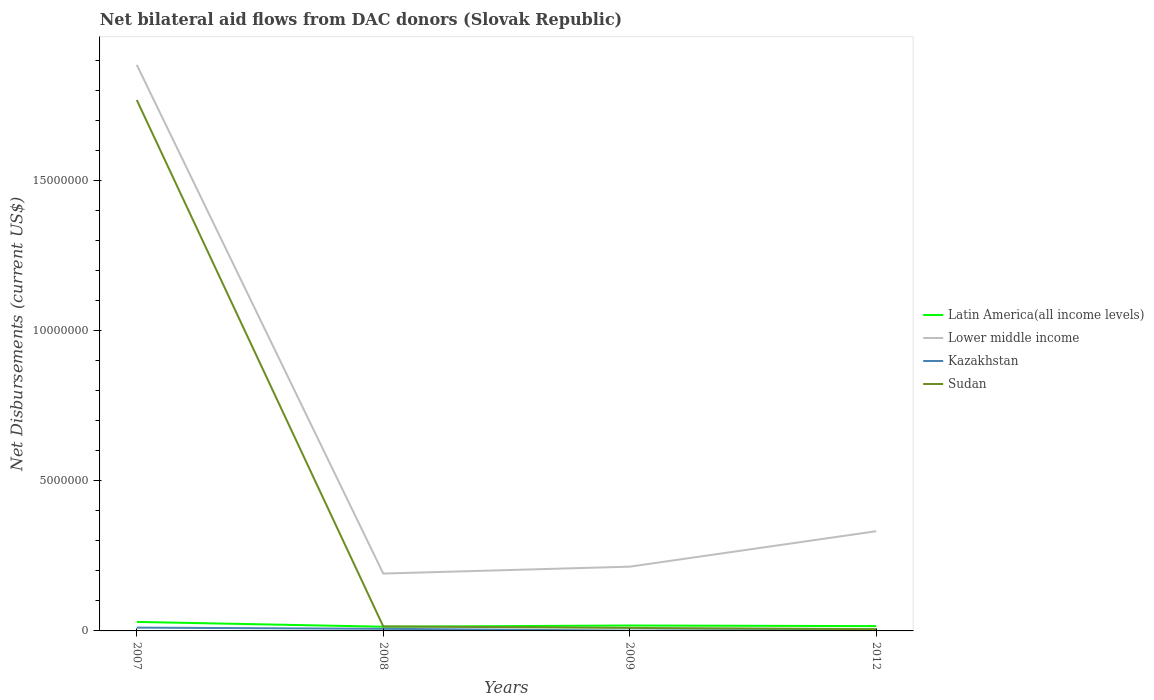Does the line corresponding to Lower middle income intersect with the line corresponding to Latin America(all income levels)?
Offer a very short reply. No. Is the number of lines equal to the number of legend labels?
Ensure brevity in your answer.  Yes. Across all years, what is the maximum net bilateral aid flows in Lower middle income?
Your answer should be compact. 1.91e+06. What is the difference between the highest and the second highest net bilateral aid flows in Latin America(all income levels)?
Your answer should be very brief. 1.60e+05. What is the difference between the highest and the lowest net bilateral aid flows in Sudan?
Provide a succinct answer. 1. Is the net bilateral aid flows in Lower middle income strictly greater than the net bilateral aid flows in Sudan over the years?
Your answer should be compact. No. How many lines are there?
Your response must be concise. 4. Does the graph contain any zero values?
Your response must be concise. No. Does the graph contain grids?
Your response must be concise. No. Where does the legend appear in the graph?
Provide a short and direct response. Center right. How are the legend labels stacked?
Keep it short and to the point. Vertical. What is the title of the graph?
Make the answer very short. Net bilateral aid flows from DAC donors (Slovak Republic). Does "France" appear as one of the legend labels in the graph?
Ensure brevity in your answer.  No. What is the label or title of the X-axis?
Make the answer very short. Years. What is the label or title of the Y-axis?
Your response must be concise. Net Disbursements (current US$). What is the Net Disbursements (current US$) in Lower middle income in 2007?
Your response must be concise. 1.88e+07. What is the Net Disbursements (current US$) of Kazakhstan in 2007?
Keep it short and to the point. 1.10e+05. What is the Net Disbursements (current US$) in Sudan in 2007?
Offer a terse response. 1.77e+07. What is the Net Disbursements (current US$) of Latin America(all income levels) in 2008?
Your response must be concise. 1.40e+05. What is the Net Disbursements (current US$) of Lower middle income in 2008?
Provide a succinct answer. 1.91e+06. What is the Net Disbursements (current US$) in Sudan in 2008?
Offer a very short reply. 1.50e+05. What is the Net Disbursements (current US$) of Lower middle income in 2009?
Offer a very short reply. 2.14e+06. What is the Net Disbursements (current US$) in Latin America(all income levels) in 2012?
Your answer should be compact. 1.60e+05. What is the Net Disbursements (current US$) in Lower middle income in 2012?
Give a very brief answer. 3.32e+06. What is the Net Disbursements (current US$) in Sudan in 2012?
Your response must be concise. 6.00e+04. Across all years, what is the maximum Net Disbursements (current US$) in Lower middle income?
Your answer should be compact. 1.88e+07. Across all years, what is the maximum Net Disbursements (current US$) of Sudan?
Your answer should be compact. 1.77e+07. Across all years, what is the minimum Net Disbursements (current US$) of Latin America(all income levels)?
Your answer should be very brief. 1.40e+05. Across all years, what is the minimum Net Disbursements (current US$) in Lower middle income?
Your answer should be compact. 1.91e+06. Across all years, what is the minimum Net Disbursements (current US$) in Kazakhstan?
Your response must be concise. 10000. Across all years, what is the minimum Net Disbursements (current US$) of Sudan?
Offer a terse response. 6.00e+04. What is the total Net Disbursements (current US$) of Latin America(all income levels) in the graph?
Give a very brief answer. 7.80e+05. What is the total Net Disbursements (current US$) in Lower middle income in the graph?
Offer a terse response. 2.62e+07. What is the total Net Disbursements (current US$) of Kazakhstan in the graph?
Your response must be concise. 2.30e+05. What is the total Net Disbursements (current US$) in Sudan in the graph?
Give a very brief answer. 1.80e+07. What is the difference between the Net Disbursements (current US$) of Latin America(all income levels) in 2007 and that in 2008?
Your answer should be very brief. 1.60e+05. What is the difference between the Net Disbursements (current US$) of Lower middle income in 2007 and that in 2008?
Your response must be concise. 1.69e+07. What is the difference between the Net Disbursements (current US$) of Sudan in 2007 and that in 2008?
Your answer should be very brief. 1.75e+07. What is the difference between the Net Disbursements (current US$) in Lower middle income in 2007 and that in 2009?
Your response must be concise. 1.67e+07. What is the difference between the Net Disbursements (current US$) of Sudan in 2007 and that in 2009?
Provide a succinct answer. 1.76e+07. What is the difference between the Net Disbursements (current US$) in Latin America(all income levels) in 2007 and that in 2012?
Your answer should be very brief. 1.40e+05. What is the difference between the Net Disbursements (current US$) in Lower middle income in 2007 and that in 2012?
Your response must be concise. 1.55e+07. What is the difference between the Net Disbursements (current US$) of Kazakhstan in 2007 and that in 2012?
Your answer should be compact. 7.00e+04. What is the difference between the Net Disbursements (current US$) in Sudan in 2007 and that in 2012?
Offer a very short reply. 1.76e+07. What is the difference between the Net Disbursements (current US$) in Latin America(all income levels) in 2008 and that in 2009?
Your answer should be compact. -4.00e+04. What is the difference between the Net Disbursements (current US$) in Sudan in 2008 and that in 2009?
Ensure brevity in your answer.  5.00e+04. What is the difference between the Net Disbursements (current US$) of Latin America(all income levels) in 2008 and that in 2012?
Keep it short and to the point. -2.00e+04. What is the difference between the Net Disbursements (current US$) of Lower middle income in 2008 and that in 2012?
Ensure brevity in your answer.  -1.41e+06. What is the difference between the Net Disbursements (current US$) in Latin America(all income levels) in 2009 and that in 2012?
Offer a terse response. 2.00e+04. What is the difference between the Net Disbursements (current US$) of Lower middle income in 2009 and that in 2012?
Provide a short and direct response. -1.18e+06. What is the difference between the Net Disbursements (current US$) of Kazakhstan in 2009 and that in 2012?
Offer a terse response. -3.00e+04. What is the difference between the Net Disbursements (current US$) in Sudan in 2009 and that in 2012?
Your answer should be very brief. 4.00e+04. What is the difference between the Net Disbursements (current US$) in Latin America(all income levels) in 2007 and the Net Disbursements (current US$) in Lower middle income in 2008?
Provide a short and direct response. -1.61e+06. What is the difference between the Net Disbursements (current US$) in Lower middle income in 2007 and the Net Disbursements (current US$) in Kazakhstan in 2008?
Your answer should be compact. 1.88e+07. What is the difference between the Net Disbursements (current US$) of Lower middle income in 2007 and the Net Disbursements (current US$) of Sudan in 2008?
Provide a short and direct response. 1.87e+07. What is the difference between the Net Disbursements (current US$) of Kazakhstan in 2007 and the Net Disbursements (current US$) of Sudan in 2008?
Your answer should be compact. -4.00e+04. What is the difference between the Net Disbursements (current US$) in Latin America(all income levels) in 2007 and the Net Disbursements (current US$) in Lower middle income in 2009?
Your response must be concise. -1.84e+06. What is the difference between the Net Disbursements (current US$) in Lower middle income in 2007 and the Net Disbursements (current US$) in Kazakhstan in 2009?
Your answer should be very brief. 1.88e+07. What is the difference between the Net Disbursements (current US$) in Lower middle income in 2007 and the Net Disbursements (current US$) in Sudan in 2009?
Keep it short and to the point. 1.88e+07. What is the difference between the Net Disbursements (current US$) in Latin America(all income levels) in 2007 and the Net Disbursements (current US$) in Lower middle income in 2012?
Give a very brief answer. -3.02e+06. What is the difference between the Net Disbursements (current US$) of Latin America(all income levels) in 2007 and the Net Disbursements (current US$) of Sudan in 2012?
Make the answer very short. 2.40e+05. What is the difference between the Net Disbursements (current US$) of Lower middle income in 2007 and the Net Disbursements (current US$) of Kazakhstan in 2012?
Offer a terse response. 1.88e+07. What is the difference between the Net Disbursements (current US$) in Lower middle income in 2007 and the Net Disbursements (current US$) in Sudan in 2012?
Your answer should be very brief. 1.88e+07. What is the difference between the Net Disbursements (current US$) of Kazakhstan in 2007 and the Net Disbursements (current US$) of Sudan in 2012?
Make the answer very short. 5.00e+04. What is the difference between the Net Disbursements (current US$) of Lower middle income in 2008 and the Net Disbursements (current US$) of Kazakhstan in 2009?
Offer a terse response. 1.90e+06. What is the difference between the Net Disbursements (current US$) in Lower middle income in 2008 and the Net Disbursements (current US$) in Sudan in 2009?
Offer a very short reply. 1.81e+06. What is the difference between the Net Disbursements (current US$) in Kazakhstan in 2008 and the Net Disbursements (current US$) in Sudan in 2009?
Ensure brevity in your answer.  -3.00e+04. What is the difference between the Net Disbursements (current US$) of Latin America(all income levels) in 2008 and the Net Disbursements (current US$) of Lower middle income in 2012?
Give a very brief answer. -3.18e+06. What is the difference between the Net Disbursements (current US$) in Latin America(all income levels) in 2008 and the Net Disbursements (current US$) in Sudan in 2012?
Make the answer very short. 8.00e+04. What is the difference between the Net Disbursements (current US$) in Lower middle income in 2008 and the Net Disbursements (current US$) in Kazakhstan in 2012?
Offer a very short reply. 1.87e+06. What is the difference between the Net Disbursements (current US$) in Lower middle income in 2008 and the Net Disbursements (current US$) in Sudan in 2012?
Provide a short and direct response. 1.85e+06. What is the difference between the Net Disbursements (current US$) in Latin America(all income levels) in 2009 and the Net Disbursements (current US$) in Lower middle income in 2012?
Your answer should be very brief. -3.14e+06. What is the difference between the Net Disbursements (current US$) in Latin America(all income levels) in 2009 and the Net Disbursements (current US$) in Kazakhstan in 2012?
Your answer should be very brief. 1.40e+05. What is the difference between the Net Disbursements (current US$) of Latin America(all income levels) in 2009 and the Net Disbursements (current US$) of Sudan in 2012?
Offer a terse response. 1.20e+05. What is the difference between the Net Disbursements (current US$) in Lower middle income in 2009 and the Net Disbursements (current US$) in Kazakhstan in 2012?
Ensure brevity in your answer.  2.10e+06. What is the difference between the Net Disbursements (current US$) of Lower middle income in 2009 and the Net Disbursements (current US$) of Sudan in 2012?
Ensure brevity in your answer.  2.08e+06. What is the difference between the Net Disbursements (current US$) in Kazakhstan in 2009 and the Net Disbursements (current US$) in Sudan in 2012?
Offer a terse response. -5.00e+04. What is the average Net Disbursements (current US$) in Latin America(all income levels) per year?
Keep it short and to the point. 1.95e+05. What is the average Net Disbursements (current US$) of Lower middle income per year?
Your answer should be compact. 6.56e+06. What is the average Net Disbursements (current US$) in Kazakhstan per year?
Offer a terse response. 5.75e+04. What is the average Net Disbursements (current US$) of Sudan per year?
Keep it short and to the point. 4.50e+06. In the year 2007, what is the difference between the Net Disbursements (current US$) in Latin America(all income levels) and Net Disbursements (current US$) in Lower middle income?
Give a very brief answer. -1.86e+07. In the year 2007, what is the difference between the Net Disbursements (current US$) in Latin America(all income levels) and Net Disbursements (current US$) in Sudan?
Make the answer very short. -1.74e+07. In the year 2007, what is the difference between the Net Disbursements (current US$) in Lower middle income and Net Disbursements (current US$) in Kazakhstan?
Keep it short and to the point. 1.87e+07. In the year 2007, what is the difference between the Net Disbursements (current US$) of Lower middle income and Net Disbursements (current US$) of Sudan?
Give a very brief answer. 1.17e+06. In the year 2007, what is the difference between the Net Disbursements (current US$) in Kazakhstan and Net Disbursements (current US$) in Sudan?
Keep it short and to the point. -1.76e+07. In the year 2008, what is the difference between the Net Disbursements (current US$) of Latin America(all income levels) and Net Disbursements (current US$) of Lower middle income?
Your answer should be very brief. -1.77e+06. In the year 2008, what is the difference between the Net Disbursements (current US$) in Latin America(all income levels) and Net Disbursements (current US$) in Sudan?
Your answer should be compact. -10000. In the year 2008, what is the difference between the Net Disbursements (current US$) in Lower middle income and Net Disbursements (current US$) in Kazakhstan?
Provide a succinct answer. 1.84e+06. In the year 2008, what is the difference between the Net Disbursements (current US$) in Lower middle income and Net Disbursements (current US$) in Sudan?
Make the answer very short. 1.76e+06. In the year 2008, what is the difference between the Net Disbursements (current US$) in Kazakhstan and Net Disbursements (current US$) in Sudan?
Ensure brevity in your answer.  -8.00e+04. In the year 2009, what is the difference between the Net Disbursements (current US$) of Latin America(all income levels) and Net Disbursements (current US$) of Lower middle income?
Your answer should be compact. -1.96e+06. In the year 2009, what is the difference between the Net Disbursements (current US$) in Latin America(all income levels) and Net Disbursements (current US$) in Kazakhstan?
Give a very brief answer. 1.70e+05. In the year 2009, what is the difference between the Net Disbursements (current US$) in Latin America(all income levels) and Net Disbursements (current US$) in Sudan?
Make the answer very short. 8.00e+04. In the year 2009, what is the difference between the Net Disbursements (current US$) of Lower middle income and Net Disbursements (current US$) of Kazakhstan?
Your response must be concise. 2.13e+06. In the year 2009, what is the difference between the Net Disbursements (current US$) of Lower middle income and Net Disbursements (current US$) of Sudan?
Keep it short and to the point. 2.04e+06. In the year 2009, what is the difference between the Net Disbursements (current US$) of Kazakhstan and Net Disbursements (current US$) of Sudan?
Ensure brevity in your answer.  -9.00e+04. In the year 2012, what is the difference between the Net Disbursements (current US$) in Latin America(all income levels) and Net Disbursements (current US$) in Lower middle income?
Offer a very short reply. -3.16e+06. In the year 2012, what is the difference between the Net Disbursements (current US$) of Latin America(all income levels) and Net Disbursements (current US$) of Kazakhstan?
Provide a succinct answer. 1.20e+05. In the year 2012, what is the difference between the Net Disbursements (current US$) of Lower middle income and Net Disbursements (current US$) of Kazakhstan?
Offer a terse response. 3.28e+06. In the year 2012, what is the difference between the Net Disbursements (current US$) in Lower middle income and Net Disbursements (current US$) in Sudan?
Make the answer very short. 3.26e+06. In the year 2012, what is the difference between the Net Disbursements (current US$) in Kazakhstan and Net Disbursements (current US$) in Sudan?
Give a very brief answer. -2.00e+04. What is the ratio of the Net Disbursements (current US$) of Latin America(all income levels) in 2007 to that in 2008?
Provide a succinct answer. 2.14. What is the ratio of the Net Disbursements (current US$) of Lower middle income in 2007 to that in 2008?
Your answer should be very brief. 9.87. What is the ratio of the Net Disbursements (current US$) of Kazakhstan in 2007 to that in 2008?
Your answer should be very brief. 1.57. What is the ratio of the Net Disbursements (current US$) in Sudan in 2007 to that in 2008?
Provide a short and direct response. 117.87. What is the ratio of the Net Disbursements (current US$) in Latin America(all income levels) in 2007 to that in 2009?
Your response must be concise. 1.67. What is the ratio of the Net Disbursements (current US$) in Lower middle income in 2007 to that in 2009?
Provide a succinct answer. 8.81. What is the ratio of the Net Disbursements (current US$) in Kazakhstan in 2007 to that in 2009?
Make the answer very short. 11. What is the ratio of the Net Disbursements (current US$) of Sudan in 2007 to that in 2009?
Ensure brevity in your answer.  176.8. What is the ratio of the Net Disbursements (current US$) of Latin America(all income levels) in 2007 to that in 2012?
Your response must be concise. 1.88. What is the ratio of the Net Disbursements (current US$) of Lower middle income in 2007 to that in 2012?
Keep it short and to the point. 5.68. What is the ratio of the Net Disbursements (current US$) in Kazakhstan in 2007 to that in 2012?
Offer a terse response. 2.75. What is the ratio of the Net Disbursements (current US$) of Sudan in 2007 to that in 2012?
Give a very brief answer. 294.67. What is the ratio of the Net Disbursements (current US$) of Latin America(all income levels) in 2008 to that in 2009?
Make the answer very short. 0.78. What is the ratio of the Net Disbursements (current US$) of Lower middle income in 2008 to that in 2009?
Ensure brevity in your answer.  0.89. What is the ratio of the Net Disbursements (current US$) of Sudan in 2008 to that in 2009?
Your answer should be compact. 1.5. What is the ratio of the Net Disbursements (current US$) of Lower middle income in 2008 to that in 2012?
Keep it short and to the point. 0.58. What is the ratio of the Net Disbursements (current US$) in Kazakhstan in 2008 to that in 2012?
Provide a succinct answer. 1.75. What is the ratio of the Net Disbursements (current US$) in Sudan in 2008 to that in 2012?
Offer a very short reply. 2.5. What is the ratio of the Net Disbursements (current US$) of Lower middle income in 2009 to that in 2012?
Keep it short and to the point. 0.64. What is the ratio of the Net Disbursements (current US$) in Kazakhstan in 2009 to that in 2012?
Offer a terse response. 0.25. What is the ratio of the Net Disbursements (current US$) of Sudan in 2009 to that in 2012?
Your answer should be very brief. 1.67. What is the difference between the highest and the second highest Net Disbursements (current US$) of Latin America(all income levels)?
Ensure brevity in your answer.  1.20e+05. What is the difference between the highest and the second highest Net Disbursements (current US$) in Lower middle income?
Keep it short and to the point. 1.55e+07. What is the difference between the highest and the second highest Net Disbursements (current US$) of Kazakhstan?
Give a very brief answer. 4.00e+04. What is the difference between the highest and the second highest Net Disbursements (current US$) in Sudan?
Provide a short and direct response. 1.75e+07. What is the difference between the highest and the lowest Net Disbursements (current US$) in Latin America(all income levels)?
Your answer should be very brief. 1.60e+05. What is the difference between the highest and the lowest Net Disbursements (current US$) of Lower middle income?
Ensure brevity in your answer.  1.69e+07. What is the difference between the highest and the lowest Net Disbursements (current US$) of Sudan?
Offer a very short reply. 1.76e+07. 